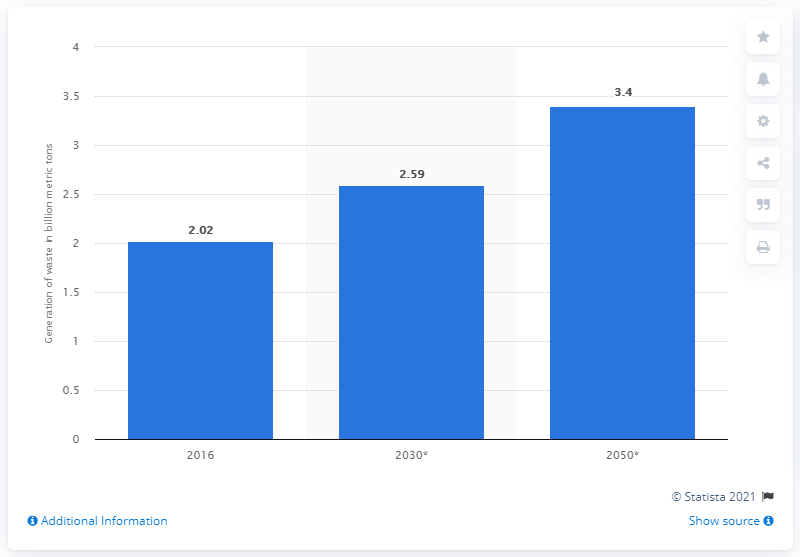Identify some key points in this picture. By 2050, it is projected that 3.4 million metric tons of municipal solid waste will be generated in . 